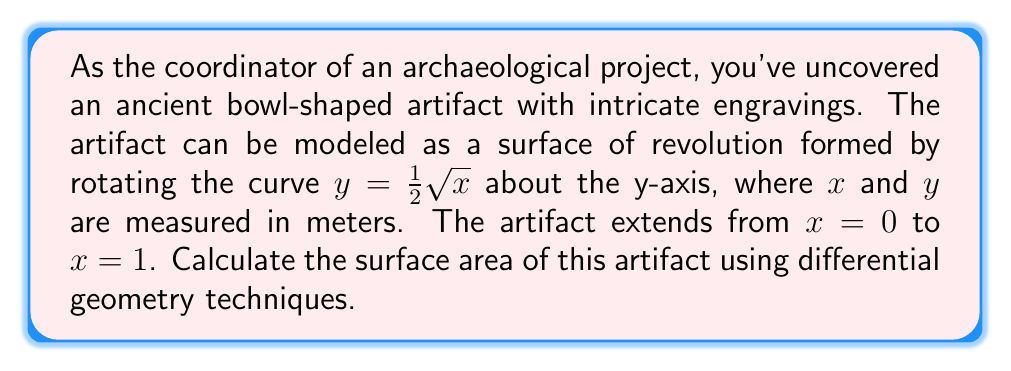Can you answer this question? To calculate the surface area of this artifact using differential geometry, we'll follow these steps:

1) For a surface of revolution formed by rotating $y = f(x)$ about the y-axis, the surface area is given by the formula:

   $$A = 2\pi \int_a^b f(x) \sqrt{1 + [f'(x)]^2} dx$$

   where $a$ and $b$ are the lower and upper bounds of $x$ respectively.

2) In our case, $f(x) = \frac{1}{2}\sqrt{x}$, $a = 0$, and $b = 1$.

3) Let's calculate $f'(x)$:
   
   $$f'(x) = \frac{1}{2} \cdot \frac{1}{2\sqrt{x}} = \frac{1}{4\sqrt{x}}$$

4) Now we can set up our integral:

   $$A = 2\pi \int_0^1 \frac{1}{2}\sqrt{x} \sqrt{1 + (\frac{1}{4\sqrt{x}})^2} dx$$

5) Simplify the expression under the square root:

   $$A = 2\pi \int_0^1 \frac{1}{2}\sqrt{x} \sqrt{1 + \frac{1}{16x}} dx$$

6) This integral is quite complex and doesn't have an elementary antiderivative. We can solve it numerically or using special functions. Using numerical integration, we get:

   $$A \approx 2\pi \cdot 0.5796$$

7) Calculating the final result:

   $$A \approx 3.6439 \text{ square meters}$$
Answer: The surface area of the artifact is approximately 3.6439 square meters. 